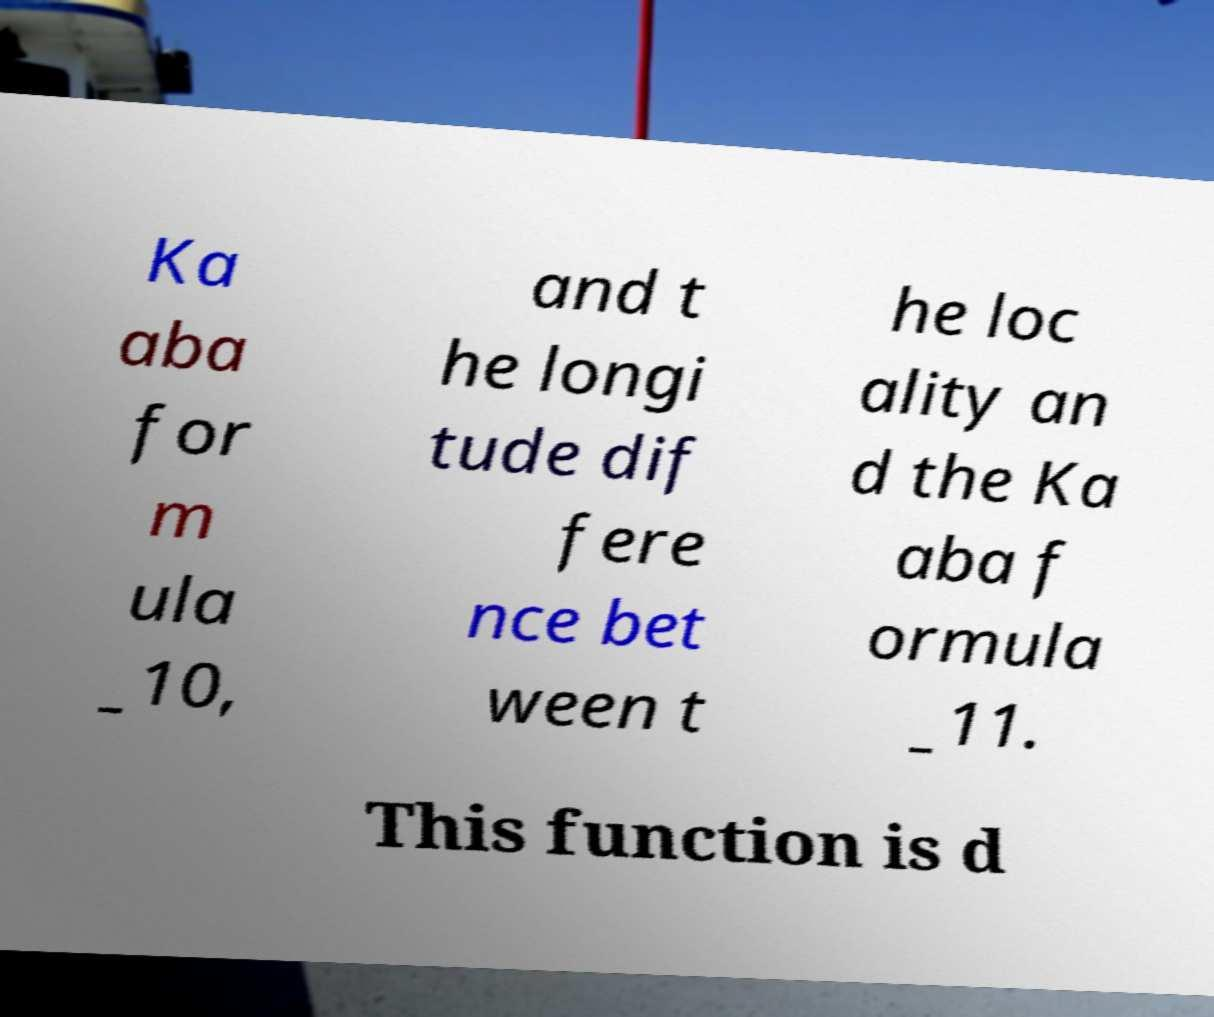For documentation purposes, I need the text within this image transcribed. Could you provide that? Ka aba for m ula _10, and t he longi tude dif fere nce bet ween t he loc ality an d the Ka aba f ormula _11. This function is d 